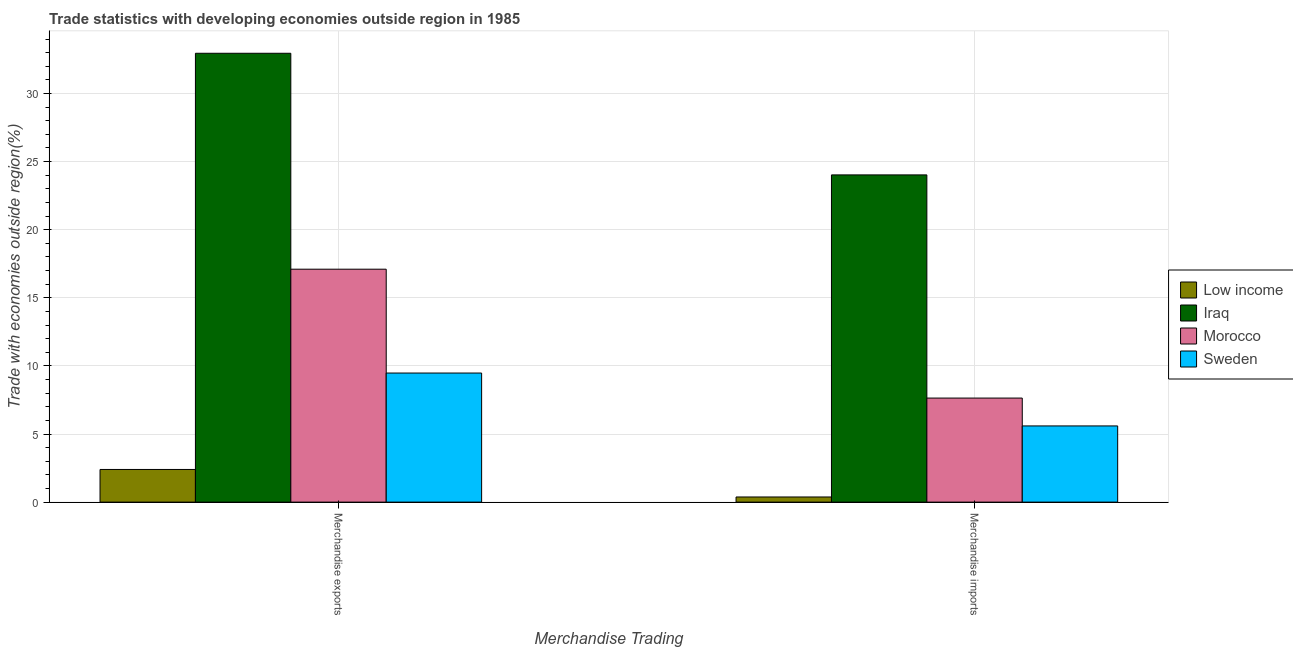How many groups of bars are there?
Make the answer very short. 2. Are the number of bars per tick equal to the number of legend labels?
Provide a succinct answer. Yes. What is the merchandise exports in Iraq?
Make the answer very short. 32.95. Across all countries, what is the maximum merchandise exports?
Your response must be concise. 32.95. Across all countries, what is the minimum merchandise exports?
Give a very brief answer. 2.4. In which country was the merchandise imports maximum?
Ensure brevity in your answer.  Iraq. In which country was the merchandise imports minimum?
Your answer should be very brief. Low income. What is the total merchandise exports in the graph?
Make the answer very short. 61.93. What is the difference between the merchandise imports in Sweden and that in Iraq?
Ensure brevity in your answer.  -18.43. What is the difference between the merchandise exports in Sweden and the merchandise imports in Low income?
Offer a very short reply. 9.1. What is the average merchandise imports per country?
Keep it short and to the point. 9.41. What is the difference between the merchandise exports and merchandise imports in Sweden?
Give a very brief answer. 3.88. In how many countries, is the merchandise imports greater than 4 %?
Your response must be concise. 3. What is the ratio of the merchandise exports in Sweden to that in Morocco?
Offer a terse response. 0.55. What does the 2nd bar from the left in Merchandise imports represents?
Offer a very short reply. Iraq. What does the 2nd bar from the right in Merchandise imports represents?
Your response must be concise. Morocco. How many bars are there?
Your response must be concise. 8. How many countries are there in the graph?
Offer a very short reply. 4. What is the difference between two consecutive major ticks on the Y-axis?
Provide a succinct answer. 5. Are the values on the major ticks of Y-axis written in scientific E-notation?
Keep it short and to the point. No. How many legend labels are there?
Your response must be concise. 4. How are the legend labels stacked?
Make the answer very short. Vertical. What is the title of the graph?
Make the answer very short. Trade statistics with developing economies outside region in 1985. Does "Namibia" appear as one of the legend labels in the graph?
Ensure brevity in your answer.  No. What is the label or title of the X-axis?
Ensure brevity in your answer.  Merchandise Trading. What is the label or title of the Y-axis?
Make the answer very short. Trade with economies outside region(%). What is the Trade with economies outside region(%) in Low income in Merchandise exports?
Offer a terse response. 2.4. What is the Trade with economies outside region(%) in Iraq in Merchandise exports?
Provide a short and direct response. 32.95. What is the Trade with economies outside region(%) in Morocco in Merchandise exports?
Provide a succinct answer. 17.1. What is the Trade with economies outside region(%) of Sweden in Merchandise exports?
Your response must be concise. 9.48. What is the Trade with economies outside region(%) of Low income in Merchandise imports?
Make the answer very short. 0.38. What is the Trade with economies outside region(%) of Iraq in Merchandise imports?
Offer a very short reply. 24.02. What is the Trade with economies outside region(%) of Morocco in Merchandise imports?
Provide a succinct answer. 7.64. What is the Trade with economies outside region(%) of Sweden in Merchandise imports?
Keep it short and to the point. 5.59. Across all Merchandise Trading, what is the maximum Trade with economies outside region(%) of Low income?
Your answer should be compact. 2.4. Across all Merchandise Trading, what is the maximum Trade with economies outside region(%) in Iraq?
Give a very brief answer. 32.95. Across all Merchandise Trading, what is the maximum Trade with economies outside region(%) in Morocco?
Provide a succinct answer. 17.1. Across all Merchandise Trading, what is the maximum Trade with economies outside region(%) in Sweden?
Provide a short and direct response. 9.48. Across all Merchandise Trading, what is the minimum Trade with economies outside region(%) of Low income?
Make the answer very short. 0.38. Across all Merchandise Trading, what is the minimum Trade with economies outside region(%) in Iraq?
Provide a succinct answer. 24.02. Across all Merchandise Trading, what is the minimum Trade with economies outside region(%) of Morocco?
Provide a succinct answer. 7.64. Across all Merchandise Trading, what is the minimum Trade with economies outside region(%) of Sweden?
Ensure brevity in your answer.  5.59. What is the total Trade with economies outside region(%) of Low income in the graph?
Keep it short and to the point. 2.78. What is the total Trade with economies outside region(%) in Iraq in the graph?
Your answer should be compact. 56.98. What is the total Trade with economies outside region(%) in Morocco in the graph?
Your answer should be compact. 24.74. What is the total Trade with economies outside region(%) in Sweden in the graph?
Provide a short and direct response. 15.07. What is the difference between the Trade with economies outside region(%) in Low income in Merchandise exports and that in Merchandise imports?
Your answer should be compact. 2.02. What is the difference between the Trade with economies outside region(%) in Iraq in Merchandise exports and that in Merchandise imports?
Your answer should be very brief. 8.93. What is the difference between the Trade with economies outside region(%) in Morocco in Merchandise exports and that in Merchandise imports?
Offer a terse response. 9.46. What is the difference between the Trade with economies outside region(%) of Sweden in Merchandise exports and that in Merchandise imports?
Provide a succinct answer. 3.88. What is the difference between the Trade with economies outside region(%) of Low income in Merchandise exports and the Trade with economies outside region(%) of Iraq in Merchandise imports?
Give a very brief answer. -21.63. What is the difference between the Trade with economies outside region(%) in Low income in Merchandise exports and the Trade with economies outside region(%) in Morocco in Merchandise imports?
Keep it short and to the point. -5.24. What is the difference between the Trade with economies outside region(%) in Low income in Merchandise exports and the Trade with economies outside region(%) in Sweden in Merchandise imports?
Ensure brevity in your answer.  -3.2. What is the difference between the Trade with economies outside region(%) of Iraq in Merchandise exports and the Trade with economies outside region(%) of Morocco in Merchandise imports?
Offer a very short reply. 25.31. What is the difference between the Trade with economies outside region(%) in Iraq in Merchandise exports and the Trade with economies outside region(%) in Sweden in Merchandise imports?
Your answer should be very brief. 27.36. What is the difference between the Trade with economies outside region(%) of Morocco in Merchandise exports and the Trade with economies outside region(%) of Sweden in Merchandise imports?
Your response must be concise. 11.51. What is the average Trade with economies outside region(%) of Low income per Merchandise Trading?
Provide a succinct answer. 1.39. What is the average Trade with economies outside region(%) in Iraq per Merchandise Trading?
Provide a short and direct response. 28.49. What is the average Trade with economies outside region(%) of Morocco per Merchandise Trading?
Keep it short and to the point. 12.37. What is the average Trade with economies outside region(%) of Sweden per Merchandise Trading?
Give a very brief answer. 7.54. What is the difference between the Trade with economies outside region(%) in Low income and Trade with economies outside region(%) in Iraq in Merchandise exports?
Ensure brevity in your answer.  -30.56. What is the difference between the Trade with economies outside region(%) of Low income and Trade with economies outside region(%) of Morocco in Merchandise exports?
Keep it short and to the point. -14.7. What is the difference between the Trade with economies outside region(%) of Low income and Trade with economies outside region(%) of Sweden in Merchandise exports?
Provide a succinct answer. -7.08. What is the difference between the Trade with economies outside region(%) of Iraq and Trade with economies outside region(%) of Morocco in Merchandise exports?
Provide a short and direct response. 15.85. What is the difference between the Trade with economies outside region(%) of Iraq and Trade with economies outside region(%) of Sweden in Merchandise exports?
Offer a terse response. 23.48. What is the difference between the Trade with economies outside region(%) of Morocco and Trade with economies outside region(%) of Sweden in Merchandise exports?
Give a very brief answer. 7.62. What is the difference between the Trade with economies outside region(%) of Low income and Trade with economies outside region(%) of Iraq in Merchandise imports?
Your answer should be compact. -23.65. What is the difference between the Trade with economies outside region(%) of Low income and Trade with economies outside region(%) of Morocco in Merchandise imports?
Your answer should be very brief. -7.26. What is the difference between the Trade with economies outside region(%) of Low income and Trade with economies outside region(%) of Sweden in Merchandise imports?
Ensure brevity in your answer.  -5.22. What is the difference between the Trade with economies outside region(%) of Iraq and Trade with economies outside region(%) of Morocco in Merchandise imports?
Your answer should be compact. 16.38. What is the difference between the Trade with economies outside region(%) in Iraq and Trade with economies outside region(%) in Sweden in Merchandise imports?
Give a very brief answer. 18.43. What is the difference between the Trade with economies outside region(%) of Morocco and Trade with economies outside region(%) of Sweden in Merchandise imports?
Ensure brevity in your answer.  2.05. What is the ratio of the Trade with economies outside region(%) in Low income in Merchandise exports to that in Merchandise imports?
Provide a succinct answer. 6.35. What is the ratio of the Trade with economies outside region(%) in Iraq in Merchandise exports to that in Merchandise imports?
Provide a succinct answer. 1.37. What is the ratio of the Trade with economies outside region(%) of Morocco in Merchandise exports to that in Merchandise imports?
Your answer should be very brief. 2.24. What is the ratio of the Trade with economies outside region(%) in Sweden in Merchandise exports to that in Merchandise imports?
Offer a very short reply. 1.69. What is the difference between the highest and the second highest Trade with economies outside region(%) in Low income?
Your answer should be very brief. 2.02. What is the difference between the highest and the second highest Trade with economies outside region(%) in Iraq?
Your answer should be very brief. 8.93. What is the difference between the highest and the second highest Trade with economies outside region(%) of Morocco?
Offer a very short reply. 9.46. What is the difference between the highest and the second highest Trade with economies outside region(%) in Sweden?
Give a very brief answer. 3.88. What is the difference between the highest and the lowest Trade with economies outside region(%) in Low income?
Ensure brevity in your answer.  2.02. What is the difference between the highest and the lowest Trade with economies outside region(%) in Iraq?
Your response must be concise. 8.93. What is the difference between the highest and the lowest Trade with economies outside region(%) in Morocco?
Offer a very short reply. 9.46. What is the difference between the highest and the lowest Trade with economies outside region(%) in Sweden?
Give a very brief answer. 3.88. 